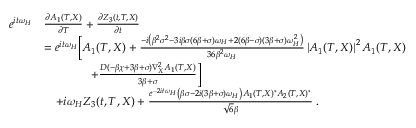<formula> <loc_0><loc_0><loc_500><loc_500>\begin{array} { r l } { e ^ { i t \omega _ { H } } } & { \frac { \partial A _ { 1 } ( T , X ) } { \partial T } + \frac { \partial Z _ { 3 } ( t , T , X ) } { \partial t } } \\ & { = e ^ { i t \omega _ { H } } \left [ A _ { 1 } ( T , X ) + \frac { - i \left ( \beta ^ { 2 } \sigma ^ { 2 } - 3 i \beta \sigma ( 6 \beta + \sigma ) \omega _ { H } + 2 ( 6 \beta - \sigma ) ( 3 \beta + \sigma ) \omega _ { H } ^ { 2 } \right ) } { 3 6 \beta ^ { 2 } \omega _ { H } } \left | A _ { 1 } ( T , X ) \right | ^ { 2 } A _ { 1 } ( T , X ) } \\ & { \quad + \frac { D ( - \beta \chi + 3 \beta + \sigma ) \nabla _ { X } ^ { 2 } A _ { 1 } ( T , X ) } { 3 \beta + \sigma } \right ] } \\ & { \quad + i \omega _ { H } Z _ { 3 } ( t , T , X ) + \frac { e ^ { - 2 i t \omega _ { H } } \left ( \beta \sigma - 2 i ( 3 \beta + \sigma ) \omega _ { H } \right ) A _ { 1 } ( T , X ) ^ { * } A _ { 2 } ( T , X ) ^ { * } } { \sqrt { 6 } \beta } \, . } \end{array}</formula> 